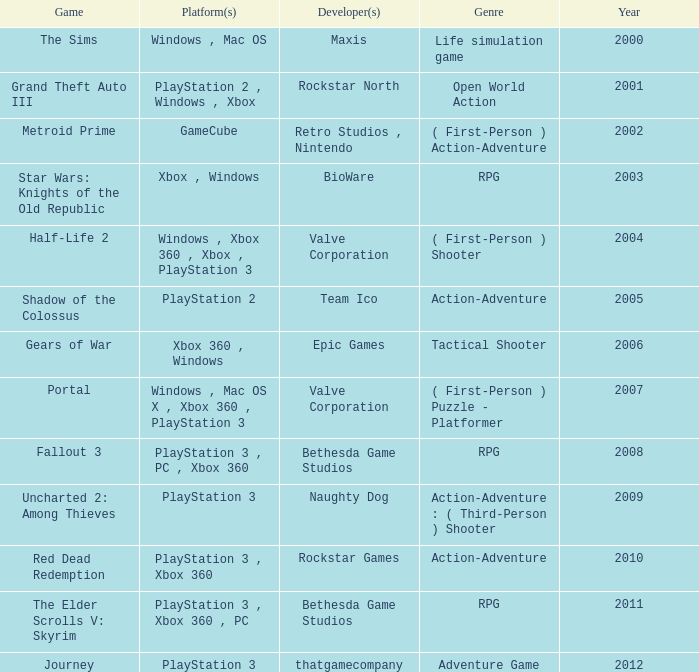What's the genre of The Sims before 2002? Life simulation game. 